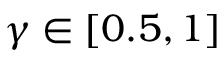Convert formula to latex. <formula><loc_0><loc_0><loc_500><loc_500>\gamma \in [ 0 . 5 , 1 ]</formula> 